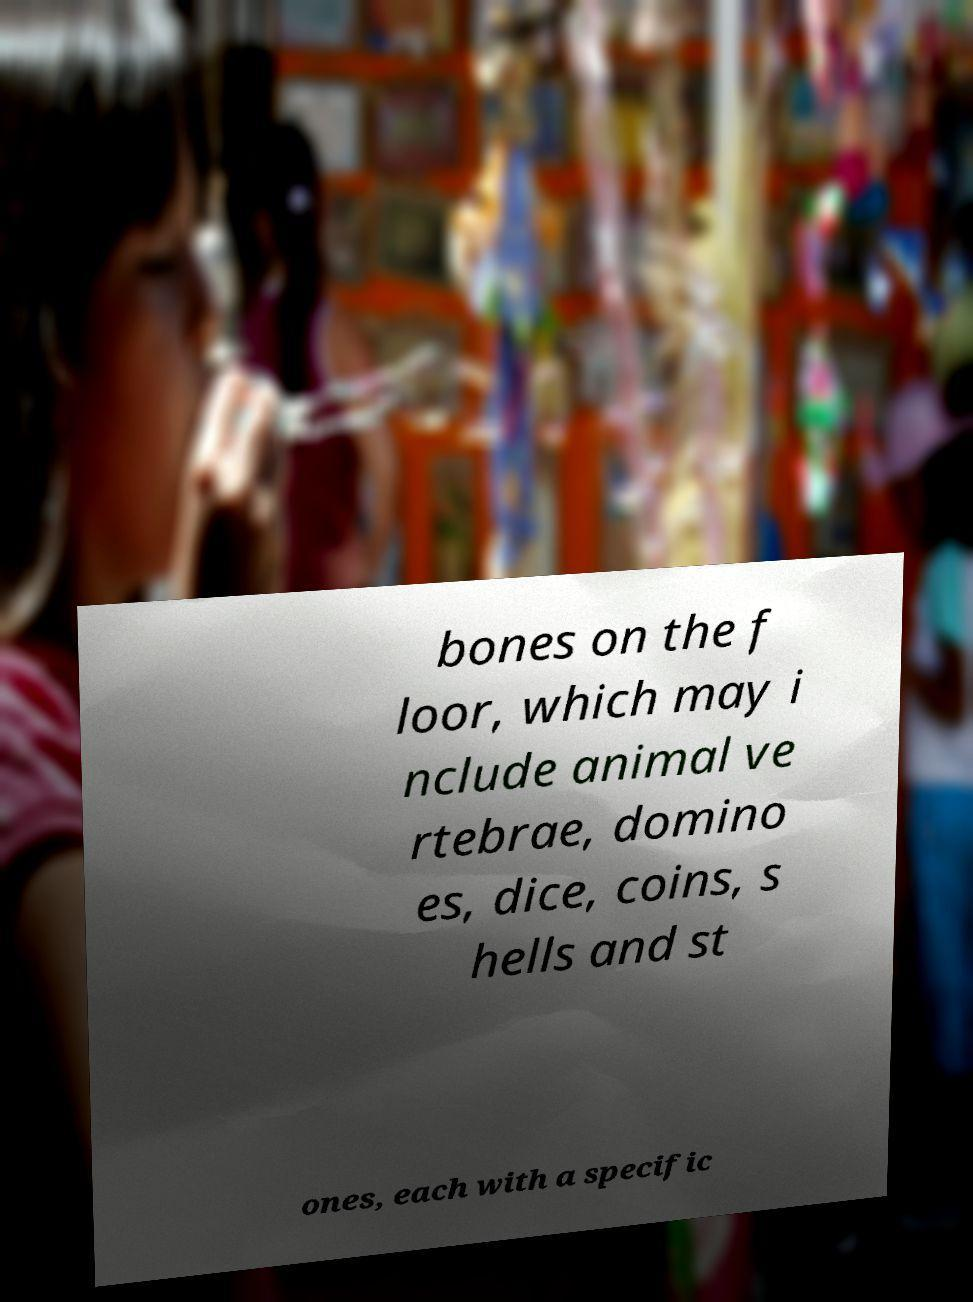Could you assist in decoding the text presented in this image and type it out clearly? bones on the f loor, which may i nclude animal ve rtebrae, domino es, dice, coins, s hells and st ones, each with a specific 